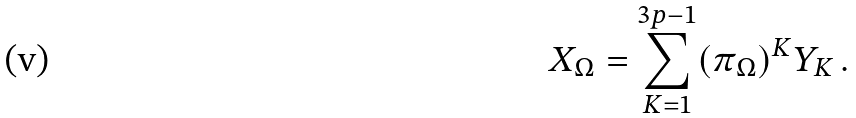Convert formula to latex. <formula><loc_0><loc_0><loc_500><loc_500>X _ { \Omega } = \sum _ { K = 1 } ^ { 3 p - 1 } ( \pi _ { \Omega } ) ^ { K } Y _ { K } \, .</formula> 